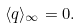Convert formula to latex. <formula><loc_0><loc_0><loc_500><loc_500>\langle q \rangle _ { \infty } = 0 .</formula> 